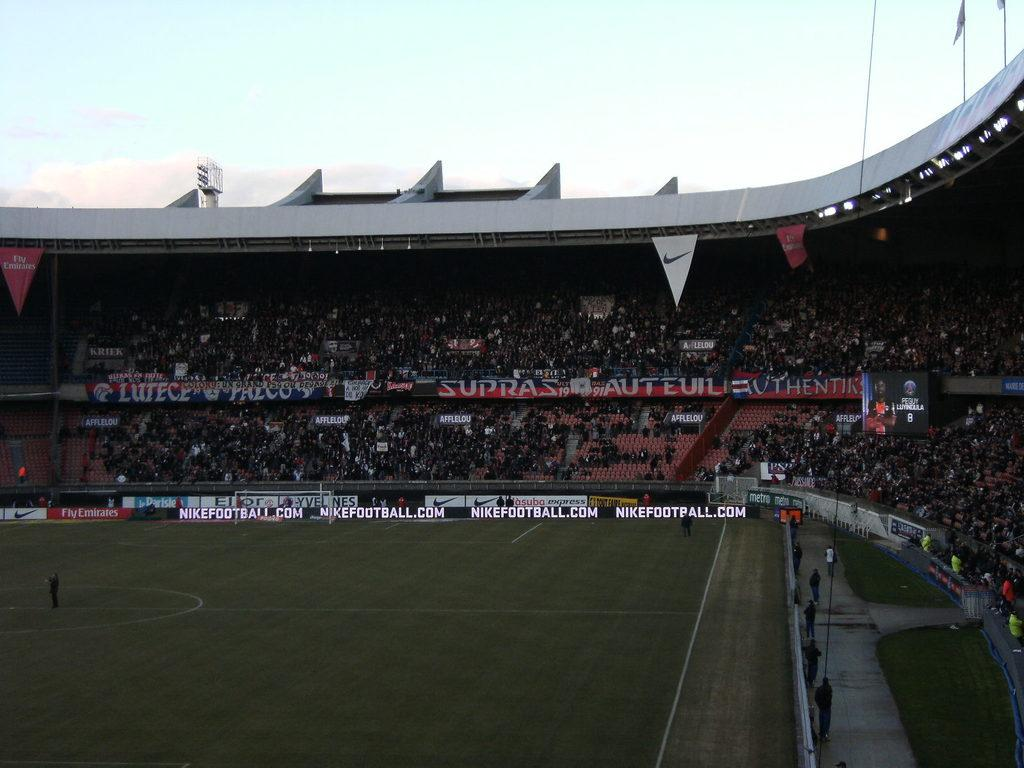<image>
Share a concise interpretation of the image provided. The website address along the fence is nikefootball.com. 